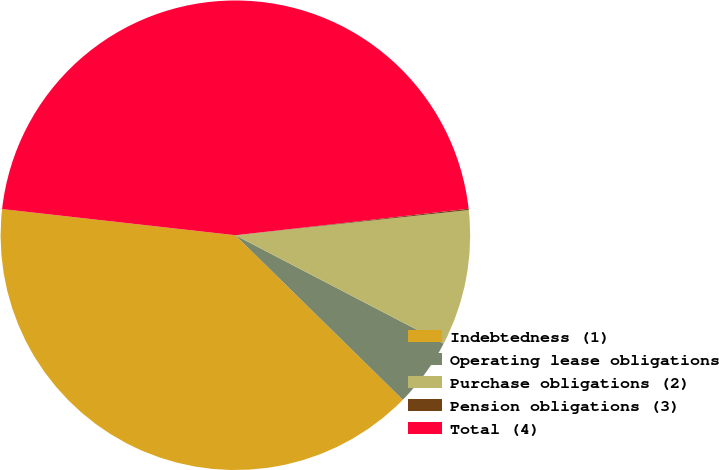<chart> <loc_0><loc_0><loc_500><loc_500><pie_chart><fcel>Indebtedness (1)<fcel>Operating lease obligations<fcel>Purchase obligations (2)<fcel>Pension obligations (3)<fcel>Total (4)<nl><fcel>39.42%<fcel>4.72%<fcel>9.35%<fcel>0.09%<fcel>46.42%<nl></chart> 